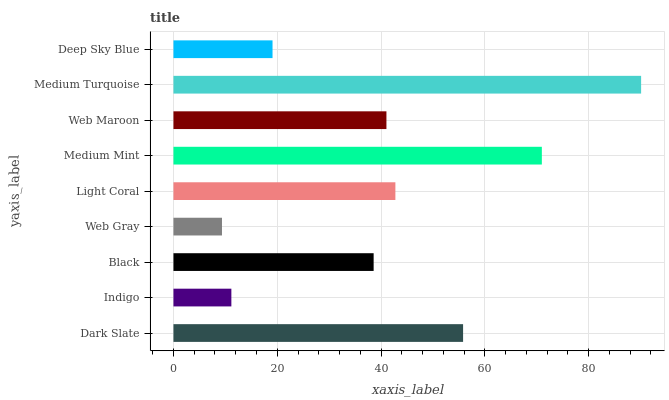Is Web Gray the minimum?
Answer yes or no. Yes. Is Medium Turquoise the maximum?
Answer yes or no. Yes. Is Indigo the minimum?
Answer yes or no. No. Is Indigo the maximum?
Answer yes or no. No. Is Dark Slate greater than Indigo?
Answer yes or no. Yes. Is Indigo less than Dark Slate?
Answer yes or no. Yes. Is Indigo greater than Dark Slate?
Answer yes or no. No. Is Dark Slate less than Indigo?
Answer yes or no. No. Is Web Maroon the high median?
Answer yes or no. Yes. Is Web Maroon the low median?
Answer yes or no. Yes. Is Light Coral the high median?
Answer yes or no. No. Is Dark Slate the low median?
Answer yes or no. No. 